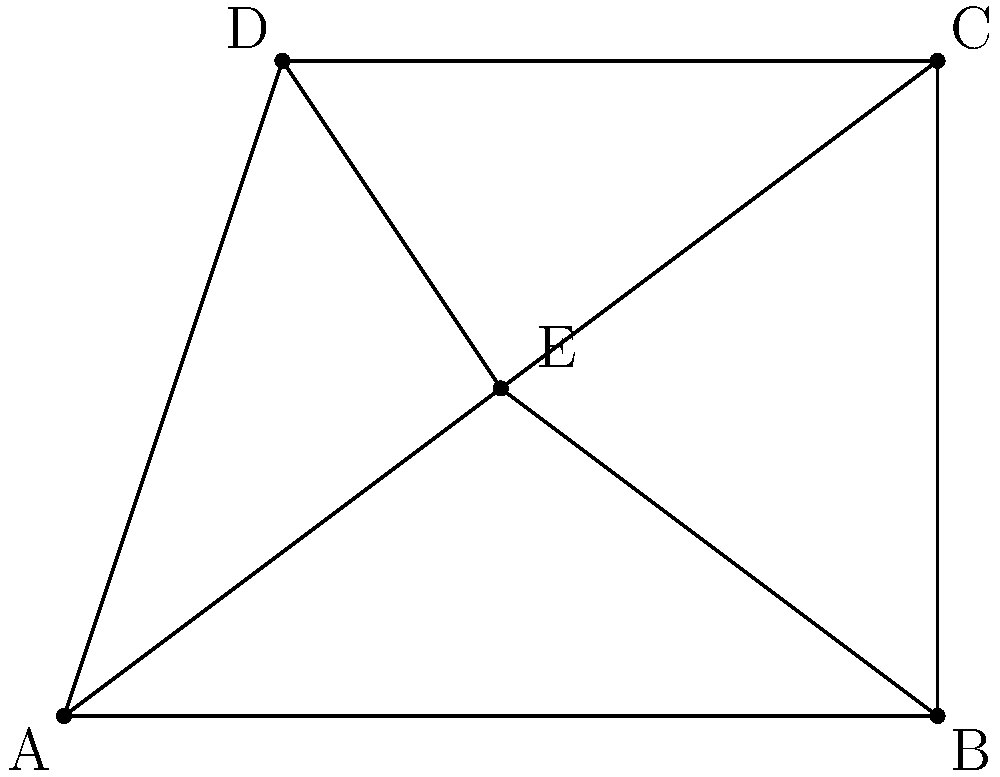In this cubist-inspired geometric composition, what is the sum of the two labeled angles formed by the intersecting lines at point E? To solve this problem, we'll follow these steps:

1. Identify the two labeled angles in the composition:
   - The angle formed by DEBa
   - The angle formed by AEC

2. Read the values of these angles from the diagram:
   - Angle DEBa = 71.6°
   - Angle AEC = 108.4°

3. Calculate the sum of these two angles:
   $$ 71.6° + 108.4° = 180° $$

4. Interpret the result:
   The sum of 180° is significant in geometry, as it represents the angles on a straight line. This demonstrates how the cubist composition, despite its abstract nature, still adheres to fundamental geometric principles.

5. Reflect on the artistic significance:
   In cubist art, the fragmentation and reassembly of shapes often create unexpected angular relationships. The fact that these two angles sum to 180° suggests a hidden order within the apparent chaos, exemplifying the interplay between chance and structure in abstract art.
Answer: 180° 